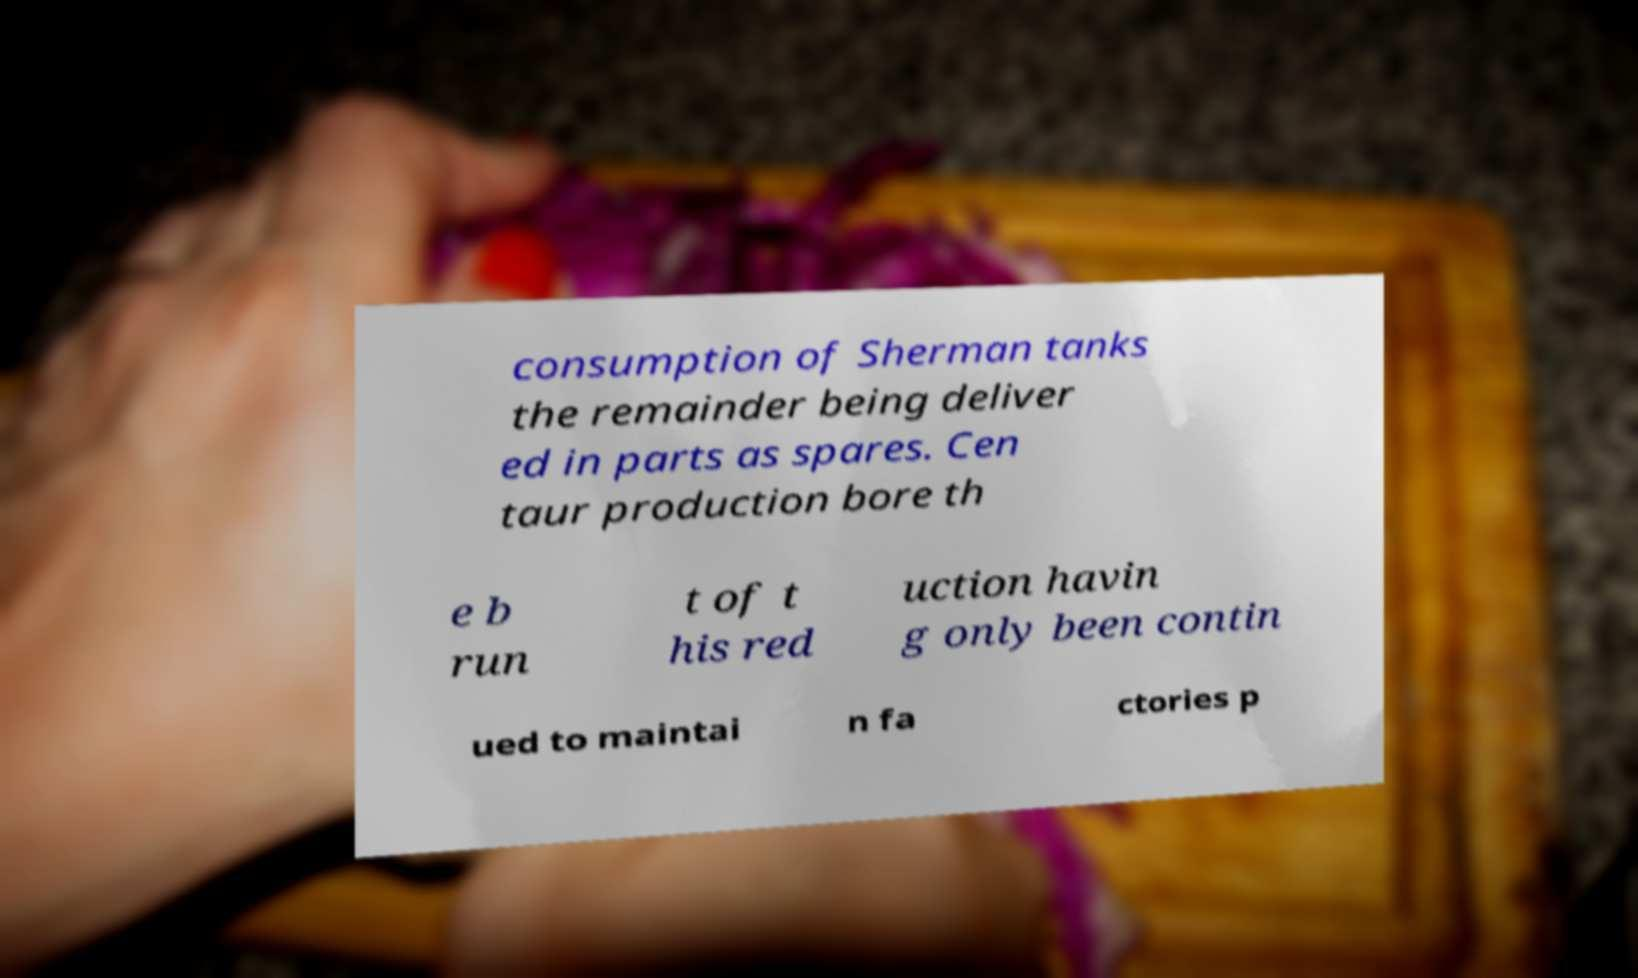Can you read and provide the text displayed in the image?This photo seems to have some interesting text. Can you extract and type it out for me? consumption of Sherman tanks the remainder being deliver ed in parts as spares. Cen taur production bore th e b run t of t his red uction havin g only been contin ued to maintai n fa ctories p 